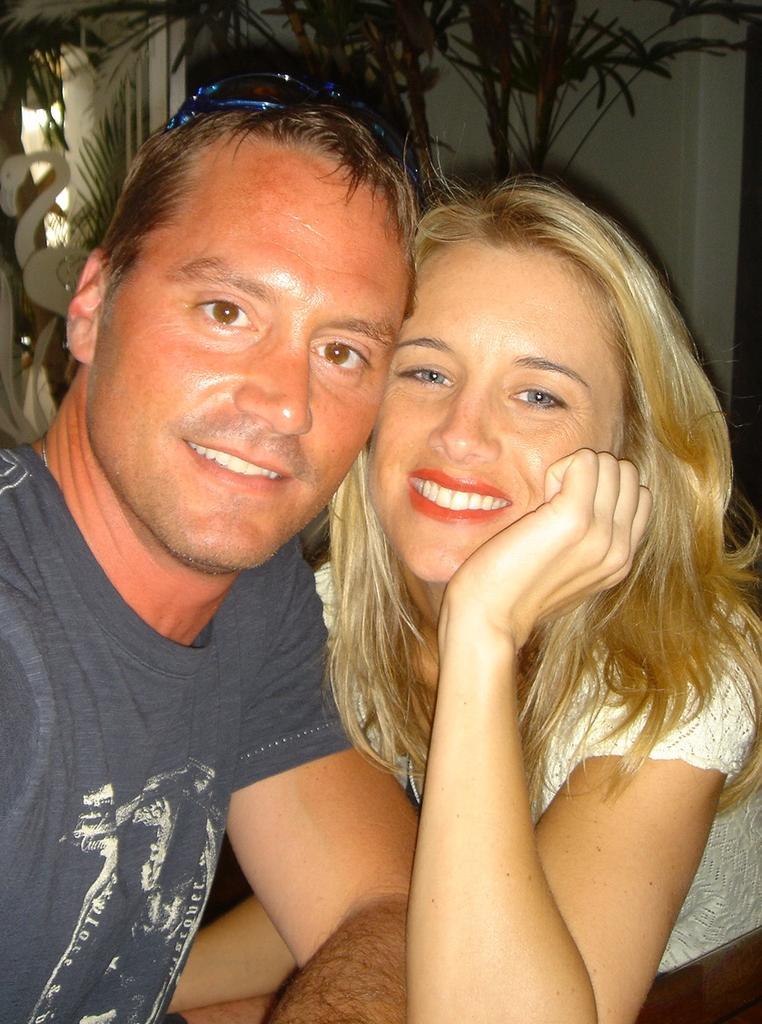Could you give a brief overview of what you see in this image? The picture of 2 persons and they are giving some stills. The woman and man are smiling. The women wore white dress and man wore blue t-shirt. The man wore goggles on his head. The wall is in white color. Far there are plants in green color. 